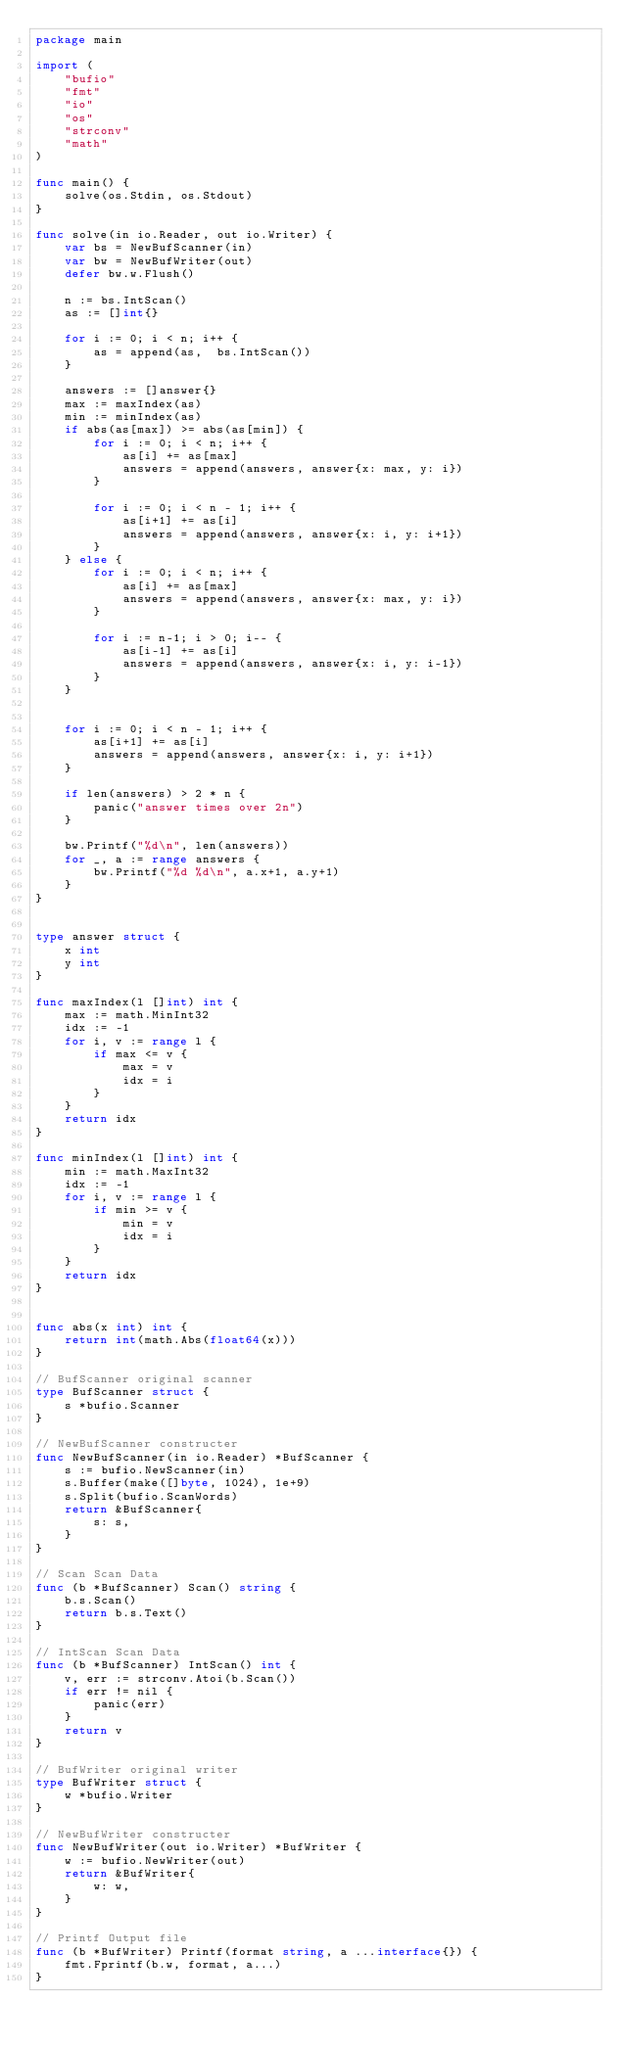Convert code to text. <code><loc_0><loc_0><loc_500><loc_500><_Go_>package main

import (
	"bufio"
	"fmt"
	"io"
	"os"
	"strconv"
	"math"
)

func main() {
	solve(os.Stdin, os.Stdout)
}

func solve(in io.Reader, out io.Writer) {
	var bs = NewBufScanner(in)
	var bw = NewBufWriter(out)
	defer bw.w.Flush()

	n := bs.IntScan()
	as := []int{}

	for i := 0; i < n; i++ {
		as = append(as,  bs.IntScan())
	}

	answers := []answer{}
	max := maxIndex(as)
	min := minIndex(as)
	if abs(as[max]) >= abs(as[min]) {
		for i := 0; i < n; i++ {
			as[i] += as[max]
			answers = append(answers, answer{x: max, y: i})
		}

		for i := 0; i < n - 1; i++ {
			as[i+1] += as[i]
			answers = append(answers, answer{x: i, y: i+1})
		}
	} else {
		for i := 0; i < n; i++ {
			as[i] += as[max]
			answers = append(answers, answer{x: max, y: i})
		}

		for i := n-1; i > 0; i-- {
			as[i-1] += as[i]
			answers = append(answers, answer{x: i, y: i-1})
		}
	}


	for i := 0; i < n - 1; i++ {
		as[i+1] += as[i]
		answers = append(answers, answer{x: i, y: i+1})
	}

	if len(answers) > 2 * n {
		panic("answer times over 2n")
	}

	bw.Printf("%d\n", len(answers))
	for _, a := range answers {
		bw.Printf("%d %d\n", a.x+1, a.y+1)
	}
}


type answer struct {
	x int
	y int
}

func maxIndex(l []int) int {
	max := math.MinInt32
	idx := -1
	for i, v := range l {
		if max <= v {
			max = v
			idx = i
		}
	}
	return idx
}

func minIndex(l []int) int {
	min := math.MaxInt32
	idx := -1
	for i, v := range l {
		if min >= v {
			min = v
			idx = i
		}
	}
	return idx
}


func abs(x int) int {
	return int(math.Abs(float64(x)))
}

// BufScanner original scanner
type BufScanner struct {
	s *bufio.Scanner
}

// NewBufScanner constructer
func NewBufScanner(in io.Reader) *BufScanner {
	s := bufio.NewScanner(in)
	s.Buffer(make([]byte, 1024), 1e+9)
	s.Split(bufio.ScanWords)
	return &BufScanner{
		s: s,
	}
}

// Scan Scan Data
func (b *BufScanner) Scan() string {
	b.s.Scan()
	return b.s.Text()
}

// IntScan Scan Data
func (b *BufScanner) IntScan() int {
	v, err := strconv.Atoi(b.Scan())
	if err != nil {
		panic(err)
	}
	return v
}

// BufWriter original writer
type BufWriter struct {
	w *bufio.Writer
}

// NewBufWriter constructer
func NewBufWriter(out io.Writer) *BufWriter {
	w := bufio.NewWriter(out)
	return &BufWriter{
		w: w,
	}
}

// Printf Output file
func (b *BufWriter) Printf(format string, a ...interface{}) {
	fmt.Fprintf(b.w, format, a...)
}</code> 